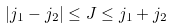Convert formula to latex. <formula><loc_0><loc_0><loc_500><loc_500>| j _ { 1 } - j _ { 2 } | \leq J \leq j _ { 1 } + j _ { 2 }</formula> 